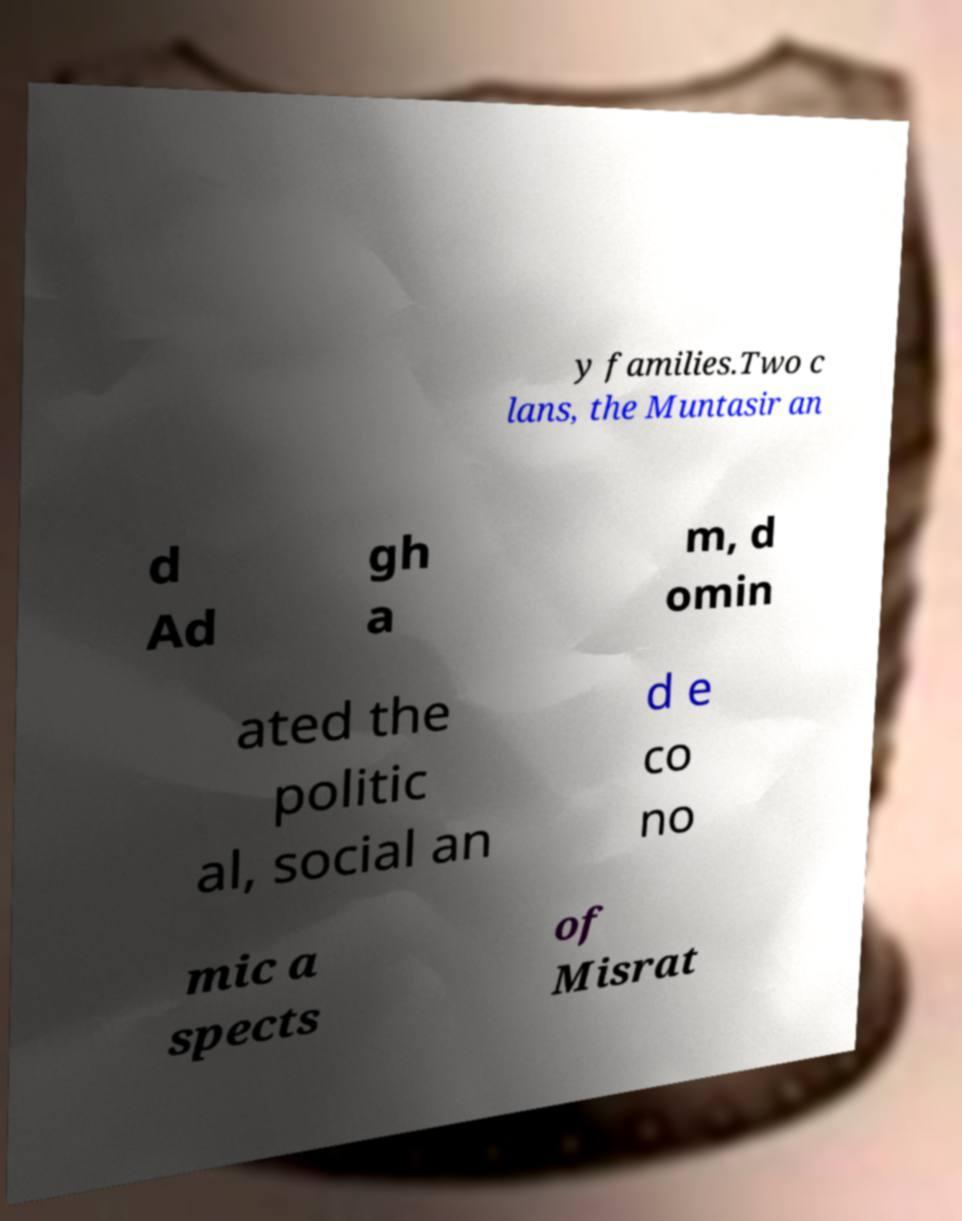For documentation purposes, I need the text within this image transcribed. Could you provide that? y families.Two c lans, the Muntasir an d Ad gh a m, d omin ated the politic al, social an d e co no mic a spects of Misrat 